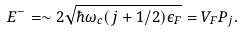<formula> <loc_0><loc_0><loc_500><loc_500>E ^ { - } = \sim 2 \sqrt { \hbar { \omega } _ { c } ( j + 1 / 2 ) \epsilon _ { F } } = V _ { F } P _ { j } .</formula> 